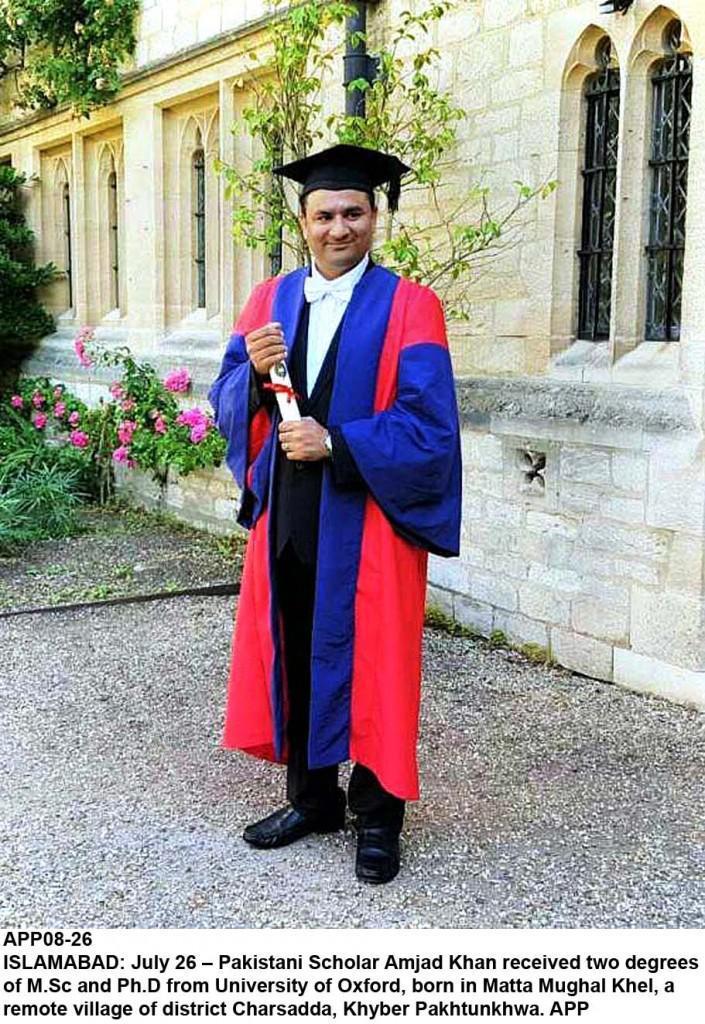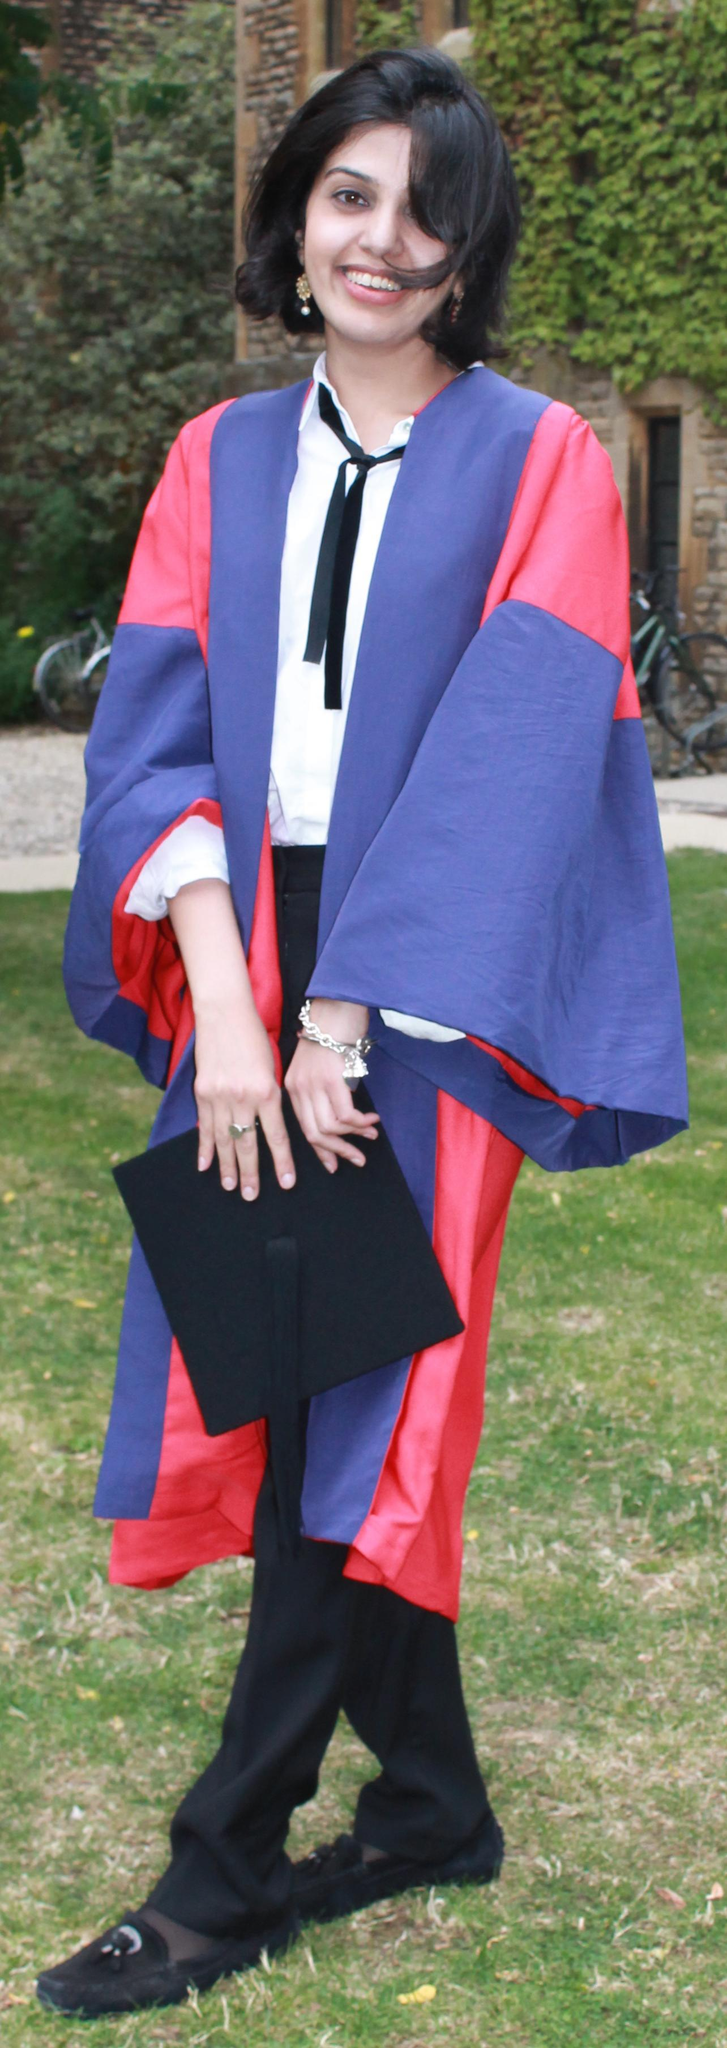The first image is the image on the left, the second image is the image on the right. Considering the images on both sides, is "There are at most 3 graduation gowns in the image pair" valid? Answer yes or no. Yes. The first image is the image on the left, the second image is the image on the right. Analyze the images presented: Is the assertion "There is a lone woman centered in one image." valid? Answer yes or no. Yes. 